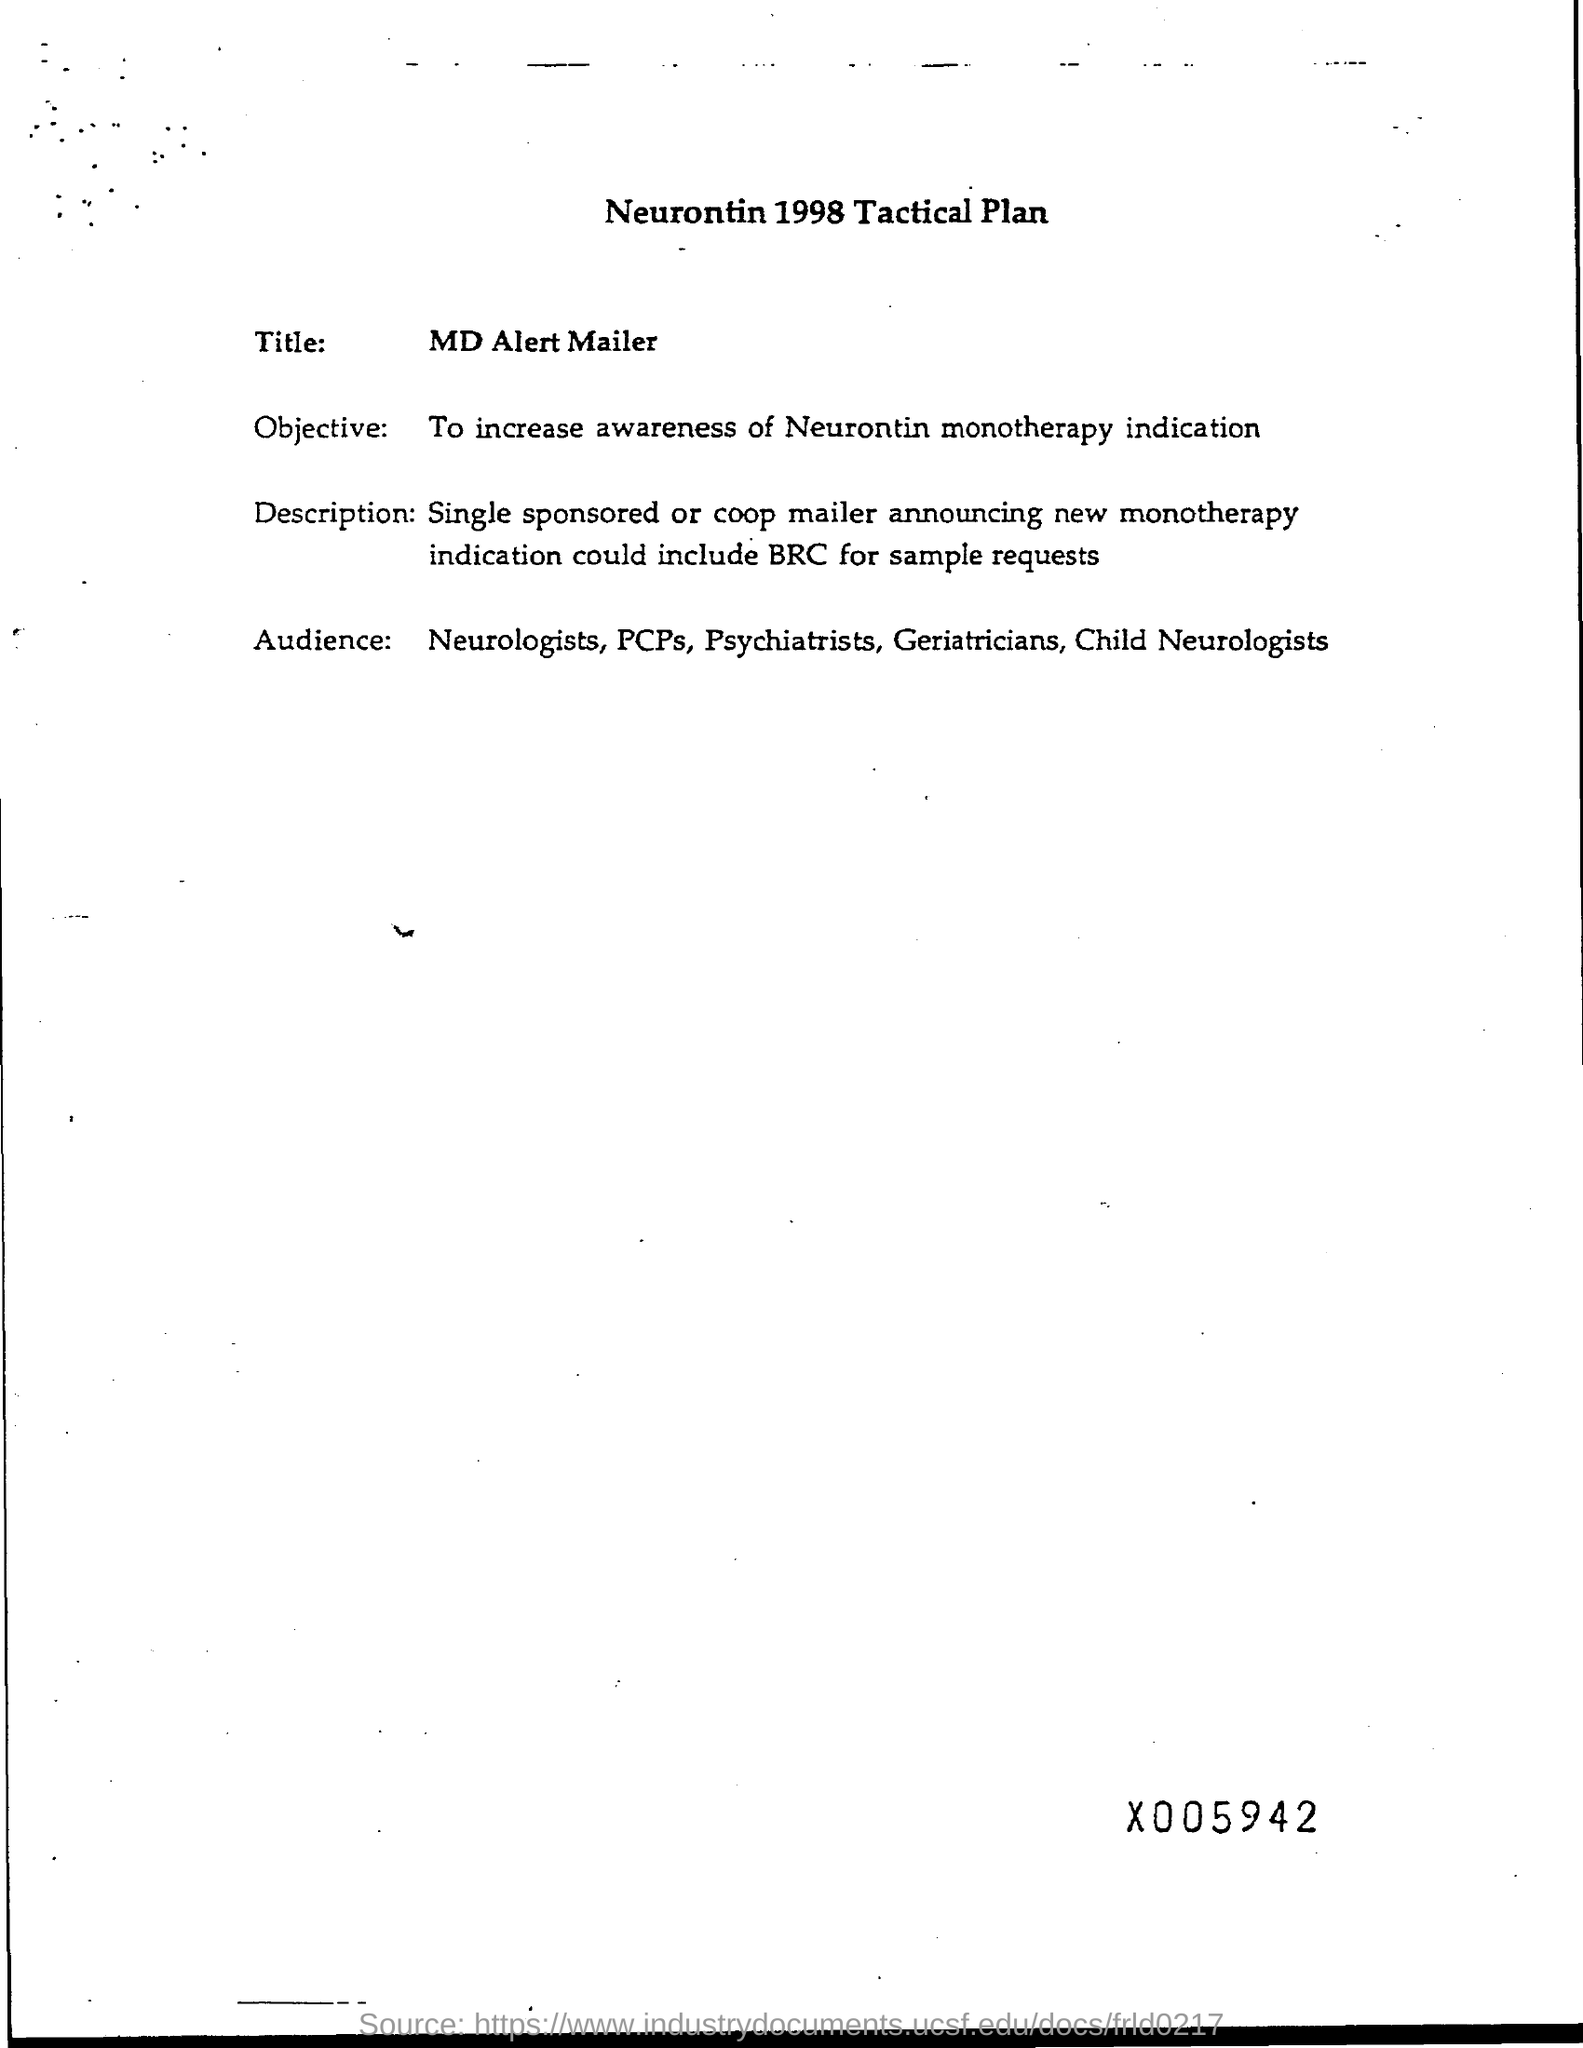What is the Title?
Offer a very short reply. MD ALERT MAILER. What is the Objective?
Offer a terse response. To increase awareness of Neurontin monotherapy indication. What is the heading?
Ensure brevity in your answer.  Neurontin 1998 Tactical Plan. 